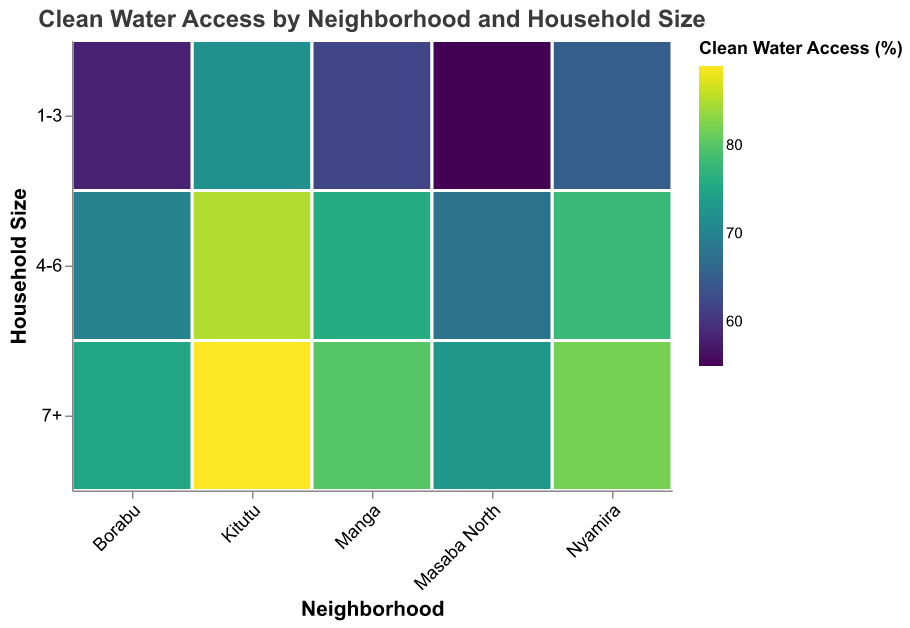What is the title of the plot? The title of the plot is usually found at the top and provides a brief description of what the plot represents. The title in this plot states: "Clean Water Access by Neighborhood and Household Size".
Answer: Clean Water Access by Neighborhood and Household Size Which neighborhood has the highest clean water access for households with 4-6 members? To find the neighborhood with the highest clean water access for the "4-6" household size, observe the rect color intensity or the legend percentage for the relevant category. Kitutu has the highest value at 85%.
Answer: Kitutu How many neighborhoods are displayed in the plot? The neighborhoods are listed along the x-axis. By counting the unique neighborhood names, we find there are five neighborhoods: Nyamira, Kitutu, Borabu, Manga, and Masaba North.
Answer: 5 What is the range of clean water access percentages for households sized 7+ in Borabu? In Borabu neighborhood for household size 7+, the plot shows the percentage value. According to the data provided, the clean water access percentage is shown as 75%.
Answer: 75% Compare the clean water access for 1-3 member households between Nyamira and Masaba North. Which neighborhood has better access? Comparing the color intensity and legend values for 1-3 member households between Nyamira and Masaba North, we see Nyamira has 65% while Masaba North has 55%. Therefore, Nyamira has better access.
Answer: Nyamira Which household size consistently has the lowest clean water access across all neighborhoods? Observing the color intensities across all household sizes and neighborhoods, the "1-3" size category consistently shows less intense colors, indicating lower access percentages across the board.
Answer: 1-3 What is the average clean water access for 7+ member households across all neighborhoods? Adding the values for 7+ member households across all neighborhoods (82, 89, 75, 80, 73) and dividing by the number of neighborhoods (5), the calculation is (82+89+75+80+73)/5 = 399/5 = 79.8%.
Answer: 79.8% Between Manga and Borabu, which has higher clean water access for 4-6 member households? Comparing the values for 4-6 member households between Manga and Borabu, Manga has 76% and Borabu has 70%. Manga has higher access.
Answer: Manga In which neighborhood do households with more than 7 members have at least 80% clean water access? Checking the plot for the 7+ member category and looking for values 80% or above, we find Nyamira (82%), Kitutu (89%), and Manga (80%) meet this criterion.
Answer: Nyamira, Kitutu, Manga 